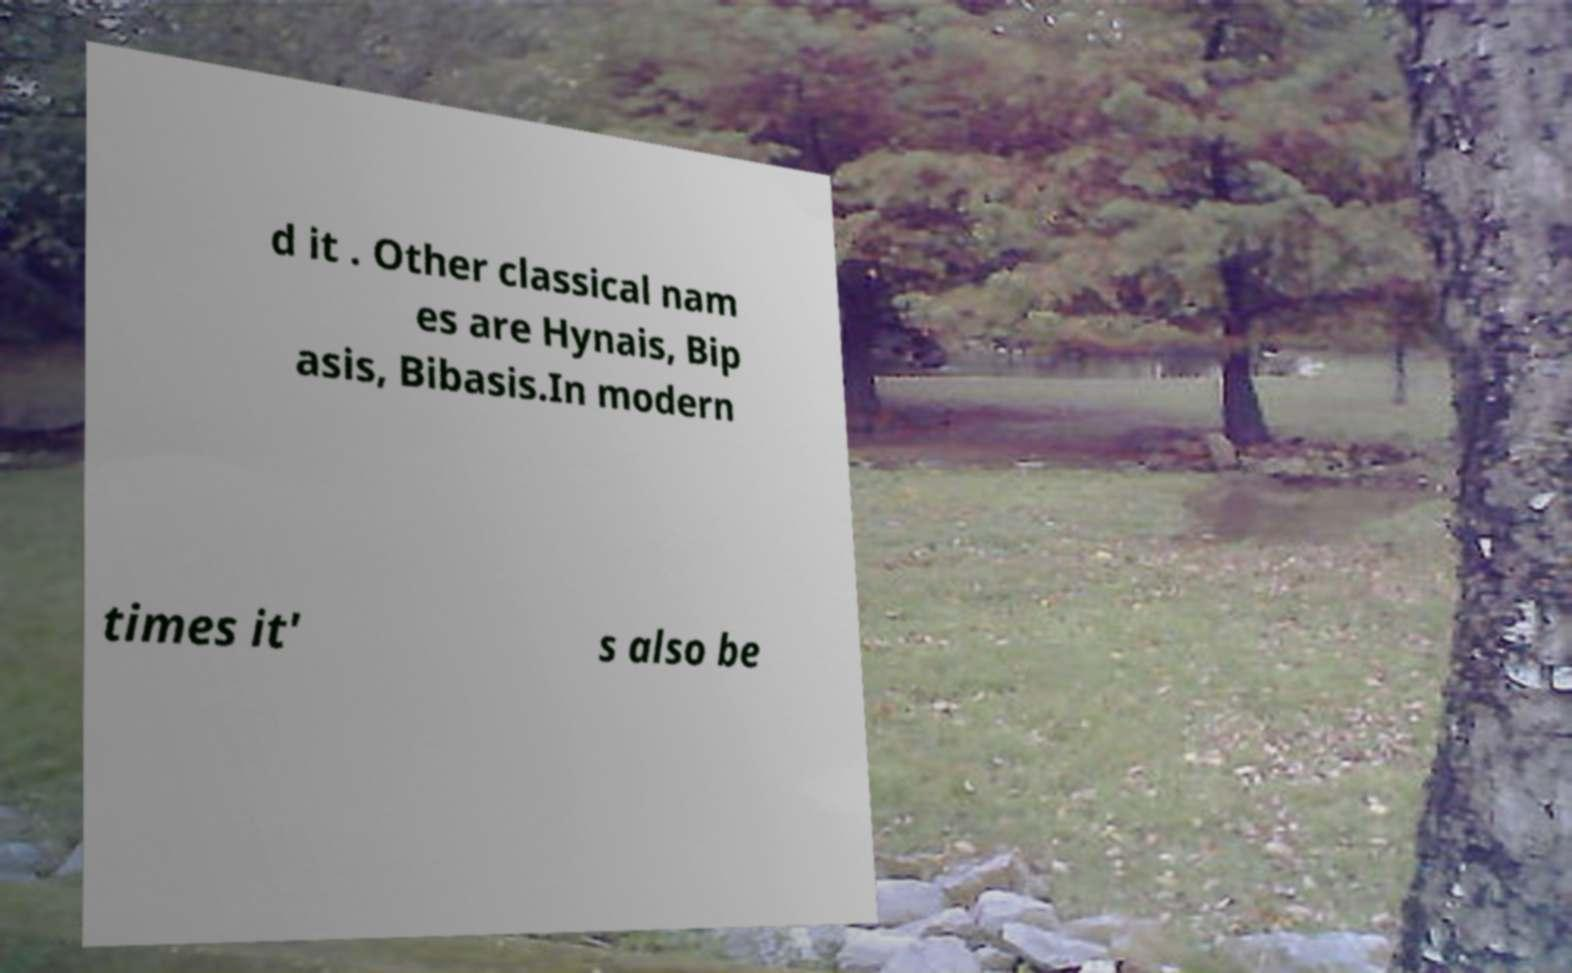I need the written content from this picture converted into text. Can you do that? d it . Other classical nam es are Hynais, Bip asis, Bibasis.In modern times it' s also be 